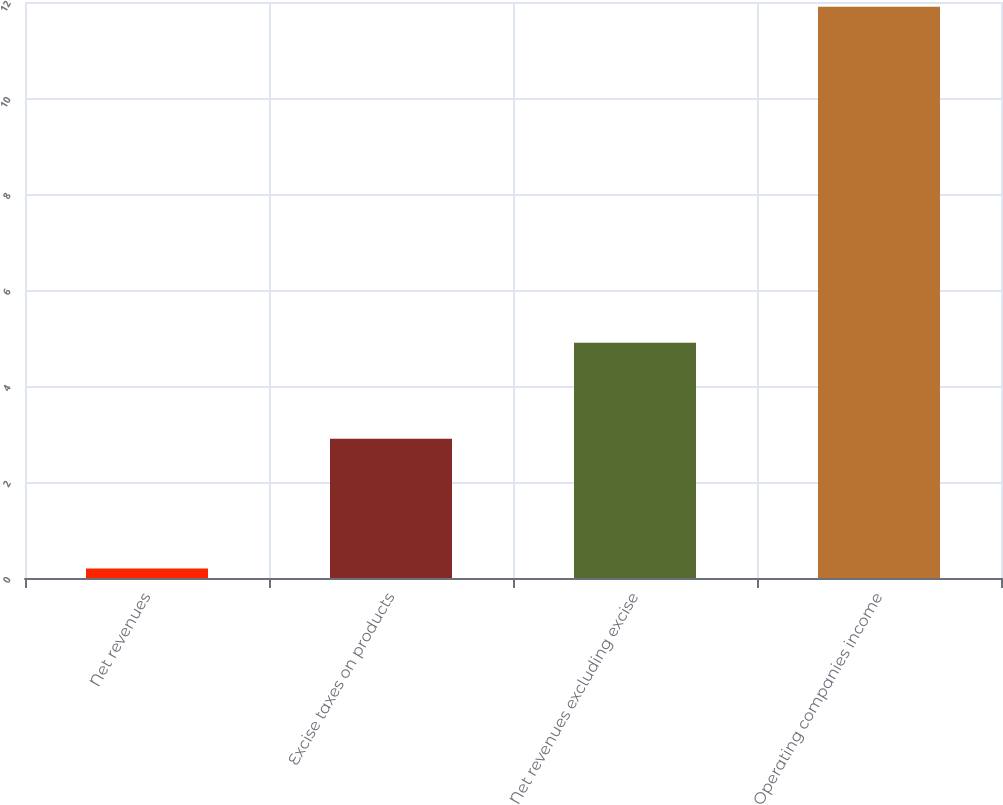<chart> <loc_0><loc_0><loc_500><loc_500><bar_chart><fcel>Net revenues<fcel>Excise taxes on products<fcel>Net revenues excluding excise<fcel>Operating companies income<nl><fcel>0.2<fcel>2.9<fcel>4.9<fcel>11.9<nl></chart> 